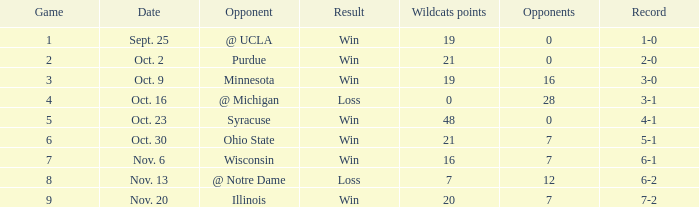How many wins or losses were there when the record was 3-0? 1.0. 